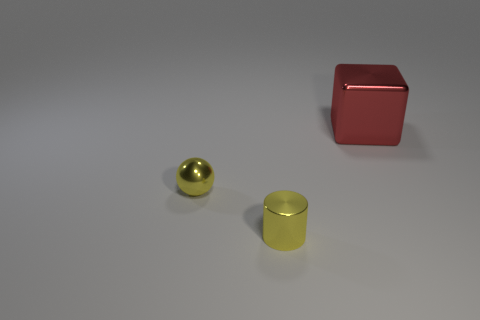Add 2 red metallic blocks. How many objects exist? 5 Subtract all balls. How many objects are left? 2 Add 3 tiny shiny cylinders. How many tiny shiny cylinders are left? 4 Add 1 tiny green balls. How many tiny green balls exist? 1 Subtract 0 gray cylinders. How many objects are left? 3 Subtract all big shiny cubes. Subtract all large brown cubes. How many objects are left? 2 